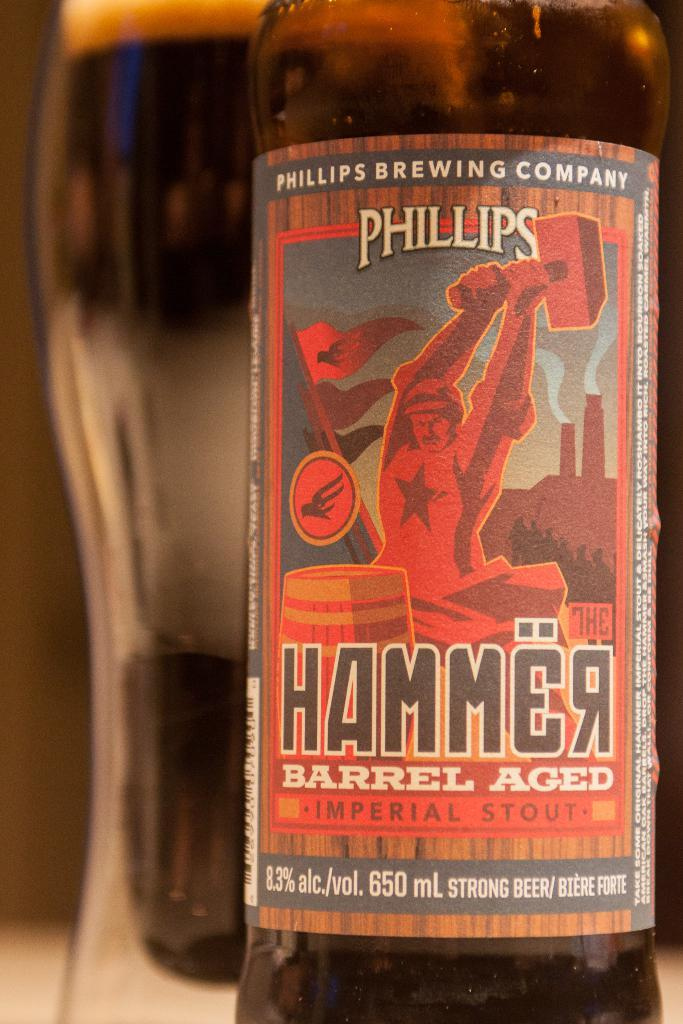<image>
Offer a succinct explanation of the picture presented. A bottle label reads Phillips Hammer barrel aged stout. 